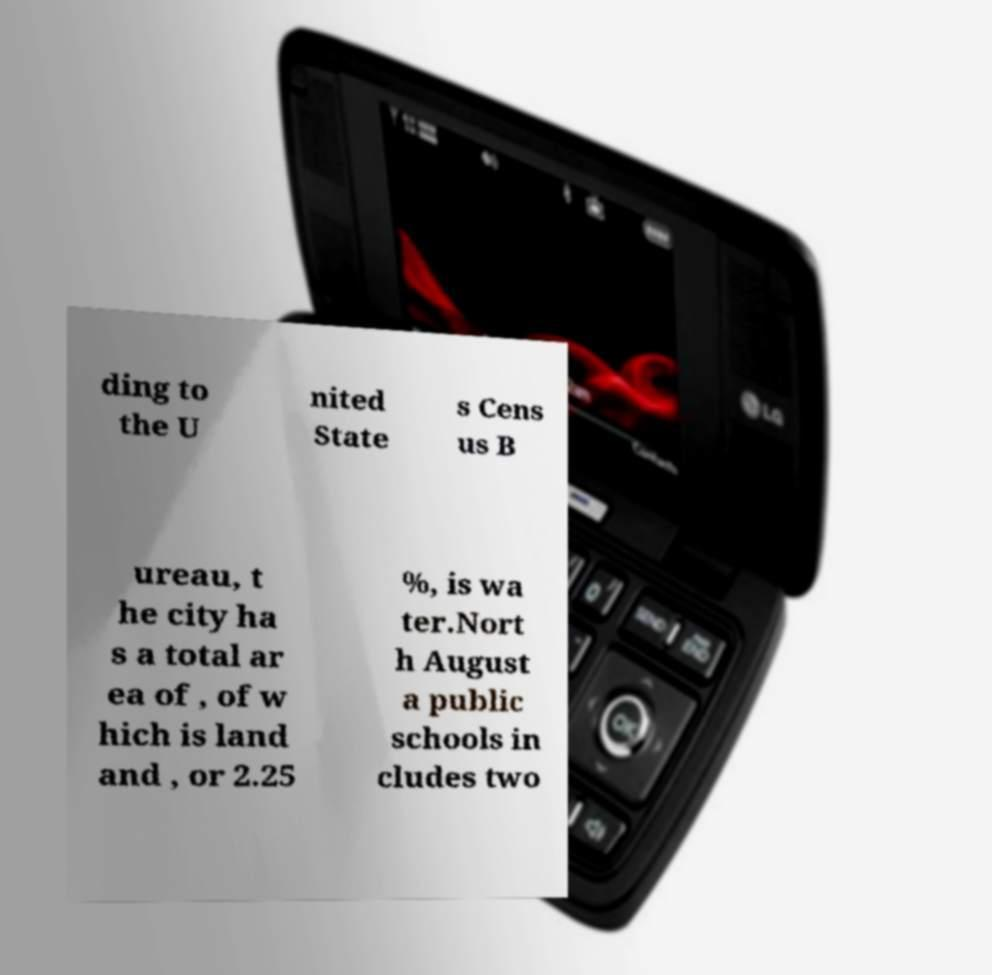Can you read and provide the text displayed in the image?This photo seems to have some interesting text. Can you extract and type it out for me? ding to the U nited State s Cens us B ureau, t he city ha s a total ar ea of , of w hich is land and , or 2.25 %, is wa ter.Nort h August a public schools in cludes two 